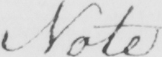What is written in this line of handwriting? Note 